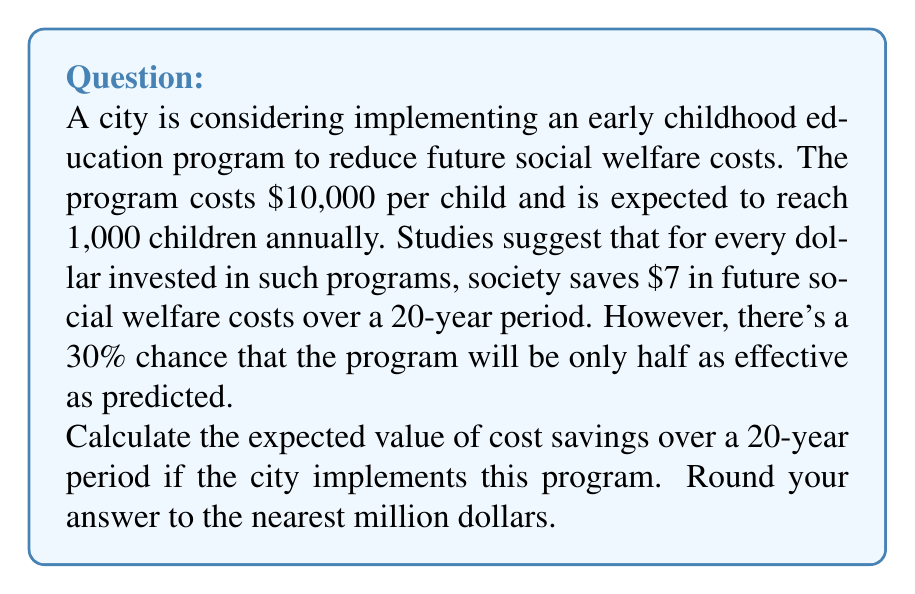Provide a solution to this math problem. Let's approach this step-by-step:

1) First, calculate the total investment:
   $10,000 per child × 1,000 children = $10,000,000 per year

2) If the program is fully effective:
   For every $1 invested, $7 is saved.
   So, $10,000,000 × 7 = $70,000,000 saved per year

3) Over 20 years, if fully effective:
   $70,000,000 × 20 = $1,400,000,000

4) If the program is half as effective:
   $70,000,000 ÷ 2 = $35,000,000 saved per year
   Over 20 years: $35,000,000 × 20 = $700,000,000

5) Now, let's calculate the expected value:
   There's a 70% chance of full effectiveness and a 30% chance of half effectiveness.

   Expected Value = (Probability of full effectiveness × Savings if fully effective) + 
                    (Probability of half effectiveness × Savings if half effective)

   $EV = (0.7 × $1,400,000,000) + (0.3 × $700,000,000)$
   $EV = $980,000,000 + $210,000,000$
   $EV = $1,190,000,000$

6) Rounding to the nearest million:
   $1,190,000,000 ≈ $1,190,000,000
Answer: $1,190,000,000 